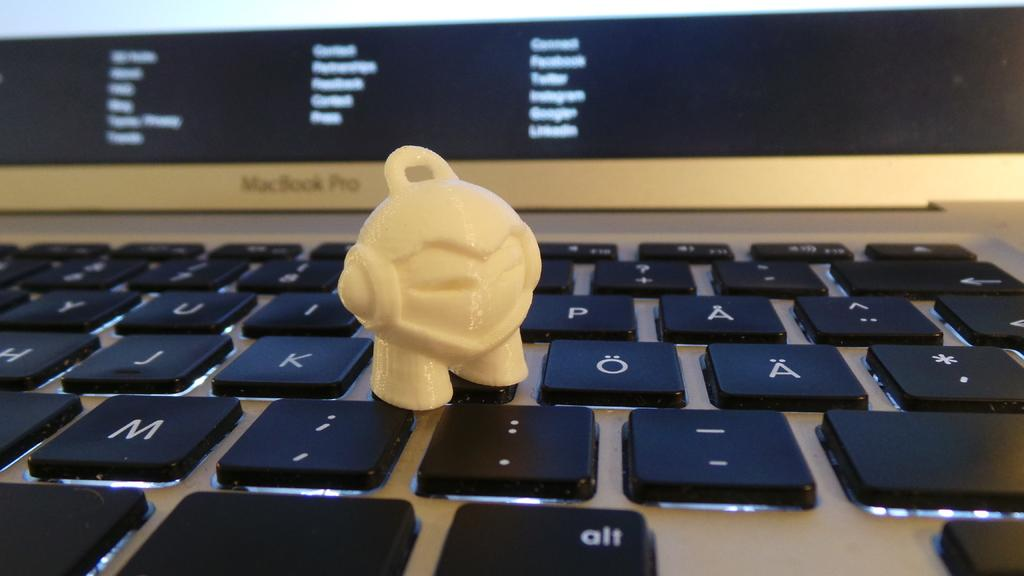<image>
Give a short and clear explanation of the subsequent image. A small toy figure rests on a black keyboard, just above the alt button. 